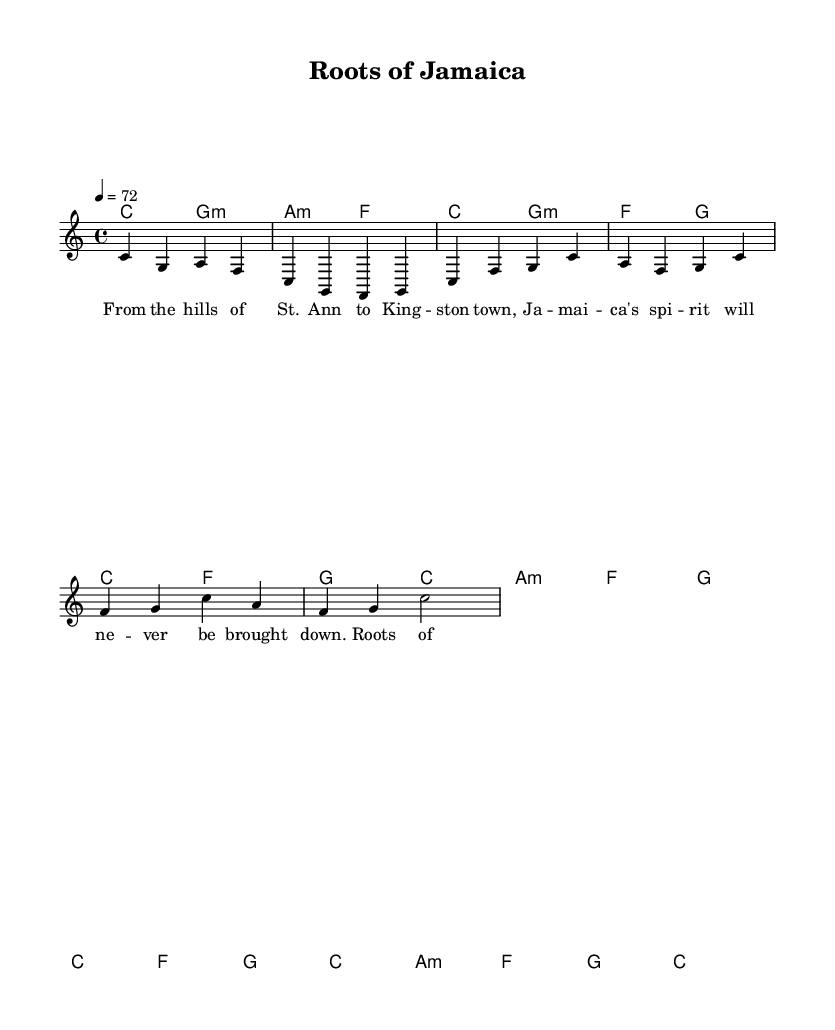What is the key signature of this music? The key signature indicated in the sheet music is C major, which is represented by the absence of any sharps or flats in the key signature.
Answer: C major What is the time signature of this music? The time signature shown is 4/4, which means there are four beats per measure and the quarter note receives one beat.
Answer: 4/4 What is the tempo marking for this piece? The tempo marking specified is 4 = 72, indicating a moderate tempo where the quarter note is played at 72 beats per minute.
Answer: 72 What is the first lyric of the verse? The first lyric shown in the verse is "From the hills of St. Ann," which is the first line of the verse notation in the sheet music.
Answer: From the hills of St. Ann How many measures are in the chorus section? By counting the measures in the chorus section, there are four measures, as indicated by the grouping of musical notes and rests in the sheet music.
Answer: 4 What style is this song classified as? The song is classified as roots reggae, which is a style known for its emphasis on Jamaican culture and heritage, as evident from the lyrics and musical structure.
Answer: Roots reggae Which chord appears most frequently in the harmonies section? The most frequently appearing chord in the harmonies section is C major, as it is used multiple times throughout both the intro and verse sections.
Answer: C 